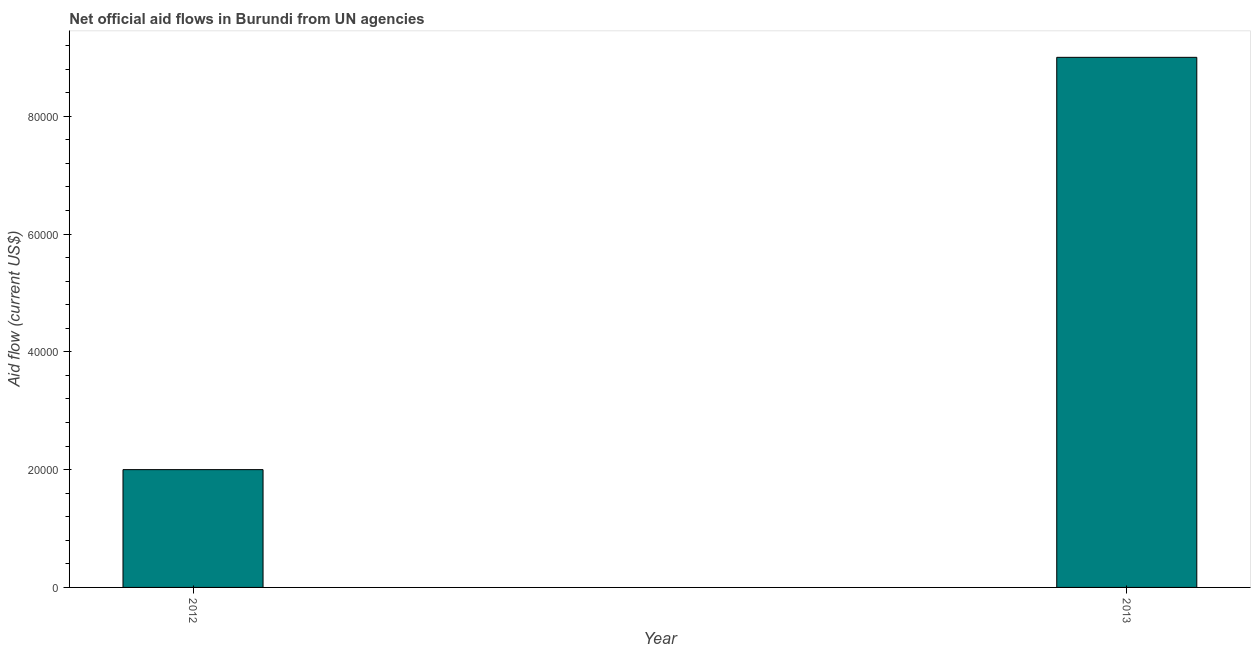Does the graph contain grids?
Provide a short and direct response. No. What is the title of the graph?
Provide a short and direct response. Net official aid flows in Burundi from UN agencies. What is the label or title of the X-axis?
Your response must be concise. Year. What is the sum of the net official flows from un agencies?
Your answer should be very brief. 1.10e+05. What is the difference between the net official flows from un agencies in 2012 and 2013?
Your response must be concise. -7.00e+04. What is the average net official flows from un agencies per year?
Your response must be concise. 5.50e+04. What is the median net official flows from un agencies?
Your answer should be very brief. 5.50e+04. In how many years, is the net official flows from un agencies greater than 36000 US$?
Your response must be concise. 1. Do a majority of the years between 2013 and 2012 (inclusive) have net official flows from un agencies greater than 64000 US$?
Give a very brief answer. No. What is the ratio of the net official flows from un agencies in 2012 to that in 2013?
Offer a terse response. 0.22. Is the net official flows from un agencies in 2012 less than that in 2013?
Offer a terse response. Yes. In how many years, is the net official flows from un agencies greater than the average net official flows from un agencies taken over all years?
Keep it short and to the point. 1. How many bars are there?
Make the answer very short. 2. How many years are there in the graph?
Make the answer very short. 2. Are the values on the major ticks of Y-axis written in scientific E-notation?
Offer a terse response. No. What is the Aid flow (current US$) of 2012?
Your response must be concise. 2.00e+04. What is the Aid flow (current US$) of 2013?
Offer a very short reply. 9.00e+04. What is the difference between the Aid flow (current US$) in 2012 and 2013?
Provide a short and direct response. -7.00e+04. What is the ratio of the Aid flow (current US$) in 2012 to that in 2013?
Provide a succinct answer. 0.22. 